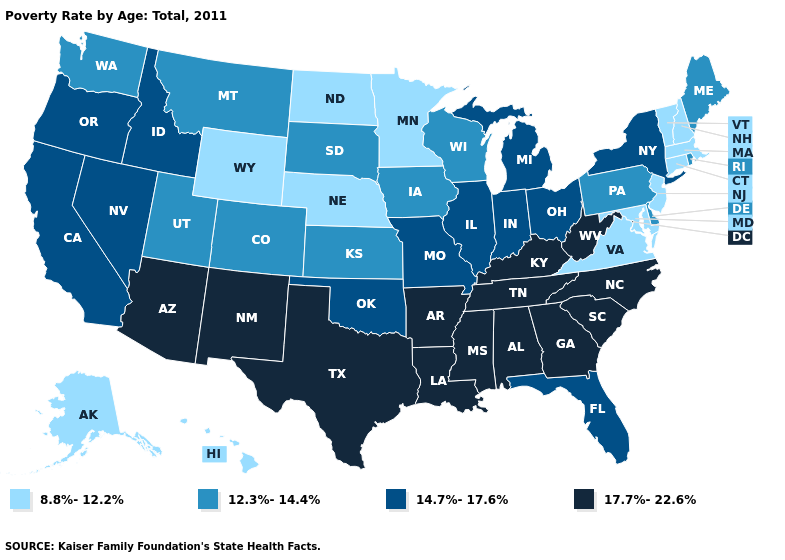Name the states that have a value in the range 8.8%-12.2%?
Concise answer only. Alaska, Connecticut, Hawaii, Maryland, Massachusetts, Minnesota, Nebraska, New Hampshire, New Jersey, North Dakota, Vermont, Virginia, Wyoming. What is the value of West Virginia?
Give a very brief answer. 17.7%-22.6%. Name the states that have a value in the range 8.8%-12.2%?
Quick response, please. Alaska, Connecticut, Hawaii, Maryland, Massachusetts, Minnesota, Nebraska, New Hampshire, New Jersey, North Dakota, Vermont, Virginia, Wyoming. What is the value of Indiana?
Keep it brief. 14.7%-17.6%. Does Vermont have the highest value in the Northeast?
Be succinct. No. Name the states that have a value in the range 8.8%-12.2%?
Give a very brief answer. Alaska, Connecticut, Hawaii, Maryland, Massachusetts, Minnesota, Nebraska, New Hampshire, New Jersey, North Dakota, Vermont, Virginia, Wyoming. What is the highest value in states that border California?
Give a very brief answer. 17.7%-22.6%. Among the states that border Nevada , which have the lowest value?
Quick response, please. Utah. What is the highest value in the Northeast ?
Concise answer only. 14.7%-17.6%. Which states hav the highest value in the Northeast?
Keep it brief. New York. Which states hav the highest value in the West?
Write a very short answer. Arizona, New Mexico. What is the value of Minnesota?
Answer briefly. 8.8%-12.2%. What is the lowest value in the South?
Short answer required. 8.8%-12.2%. Does Rhode Island have a higher value than North Dakota?
Answer briefly. Yes. 